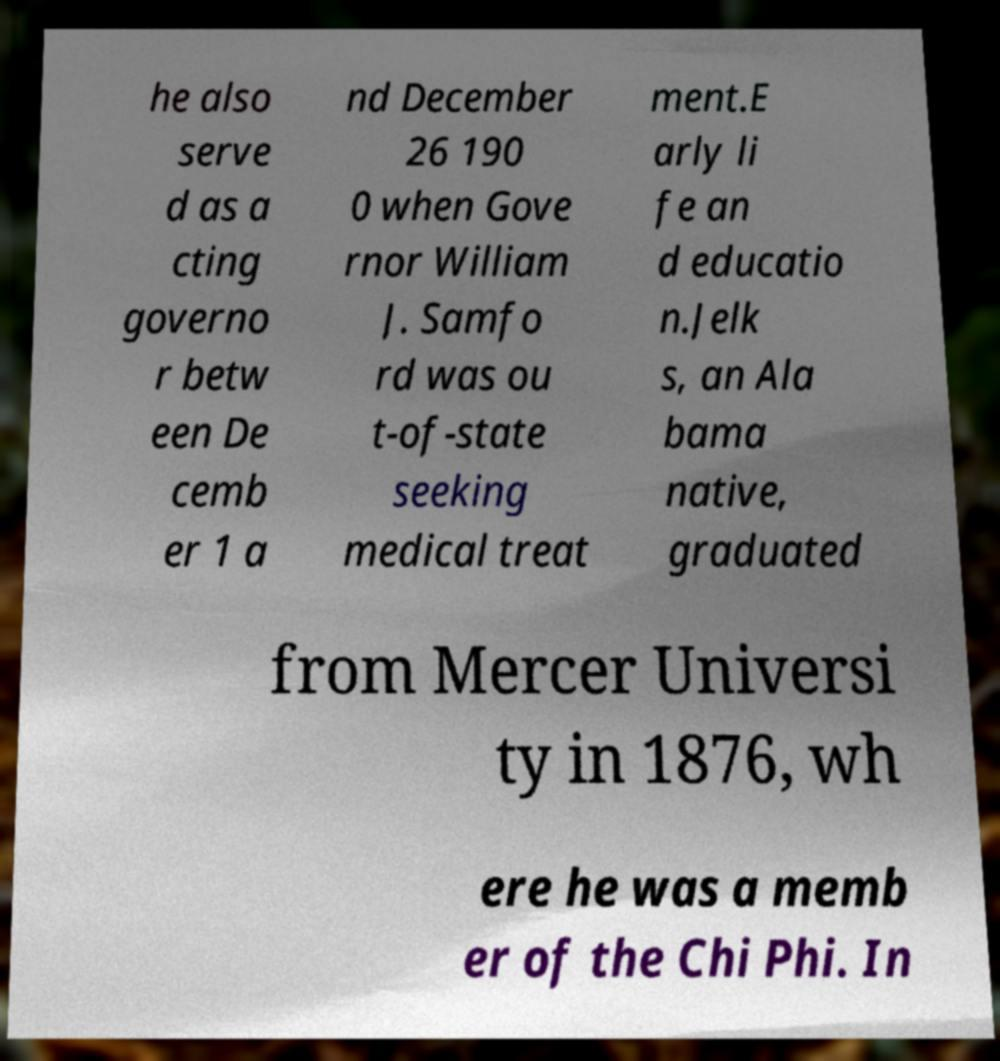Please read and relay the text visible in this image. What does it say? he also serve d as a cting governo r betw een De cemb er 1 a nd December 26 190 0 when Gove rnor William J. Samfo rd was ou t-of-state seeking medical treat ment.E arly li fe an d educatio n.Jelk s, an Ala bama native, graduated from Mercer Universi ty in 1876, wh ere he was a memb er of the Chi Phi. In 